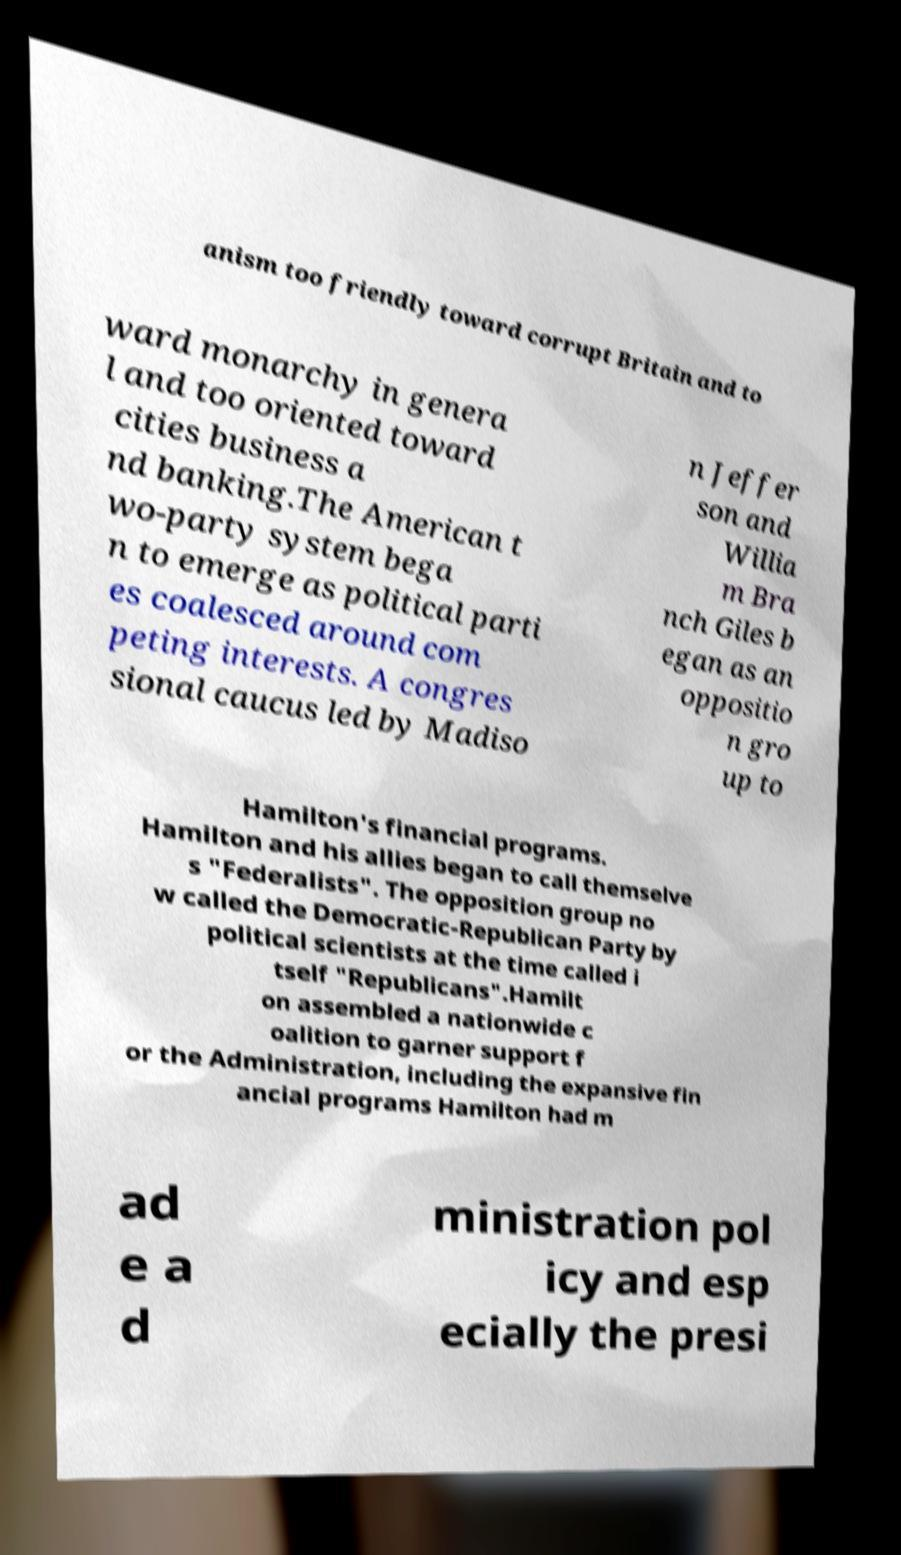I need the written content from this picture converted into text. Can you do that? anism too friendly toward corrupt Britain and to ward monarchy in genera l and too oriented toward cities business a nd banking.The American t wo-party system bega n to emerge as political parti es coalesced around com peting interests. A congres sional caucus led by Madiso n Jeffer son and Willia m Bra nch Giles b egan as an oppositio n gro up to Hamilton's financial programs. Hamilton and his allies began to call themselve s "Federalists". The opposition group no w called the Democratic-Republican Party by political scientists at the time called i tself "Republicans".Hamilt on assembled a nationwide c oalition to garner support f or the Administration, including the expansive fin ancial programs Hamilton had m ad e a d ministration pol icy and esp ecially the presi 